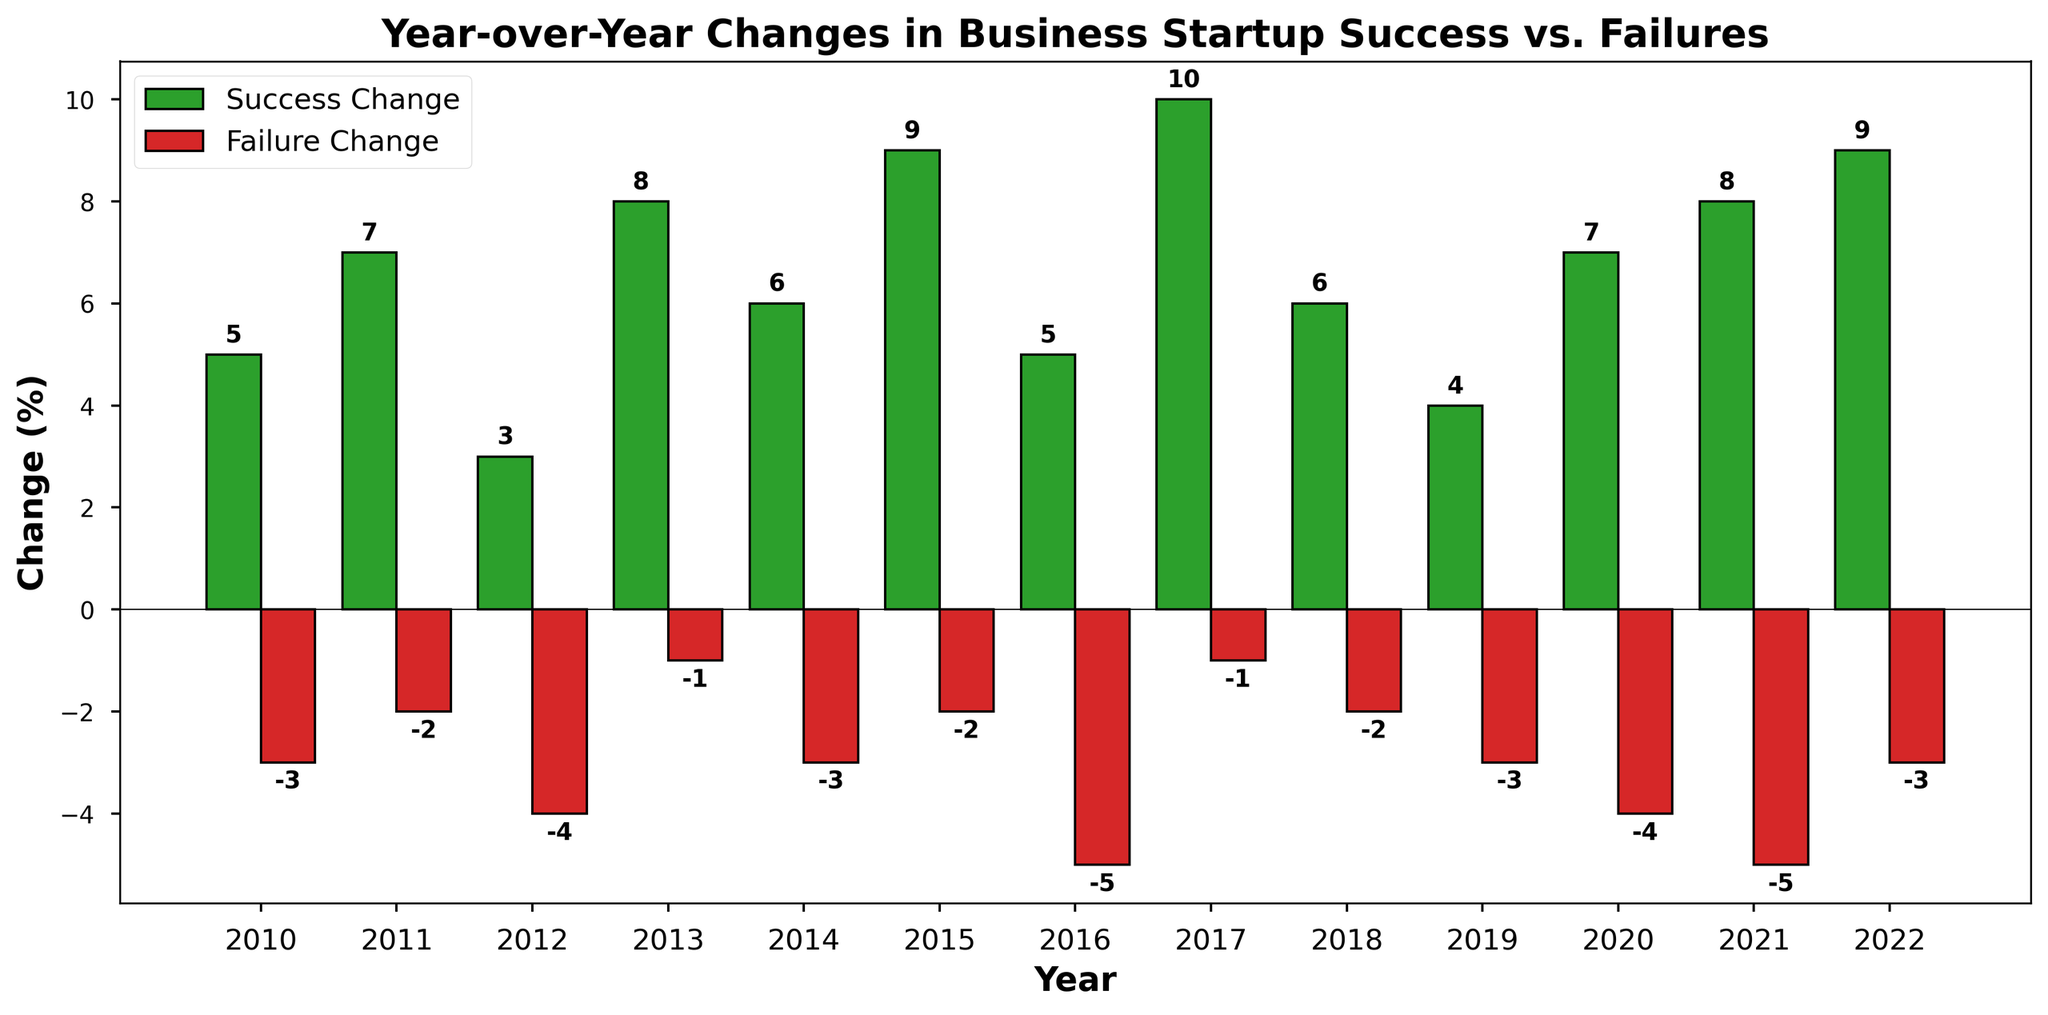In which year did the Startups Success Change have the highest value? The bars representing the Startups Success Change are in green. By visually comparing the heights of these bars, we can see that the highest value is in 2017.
Answer: 2017 What is the total change in Startups Success from 2019 to 2022? Add the values of Startups Success Change for the years 2019, 2020, 2021, and 2022: 4 + 7 + 8 + 9 = 28.
Answer: 28 Comparing 2013 and 2015, which year saw a higher decrease in Startups Failures? The bars representing the Startups Failure Change are in red. Both 2013 and 2015 are shown with red bars, and visually, the height of the red bar in 2013 (-1) is shorter in length compared to 2015 (-2).
Answer: 2015 What is the difference between the Startups Success Change and Startups Failure Change in 2011? The Startups Success Change in 2011 is 7 and the Startups Failure Change is -2. The difference is 7 - (-2) = 7 + 2 = 9.
Answer: 9 Which year had an equal value of Startups Success and Startups Failure Change? Visually, there is no year where the height of the green bar (Success) is equal to the height of the red bar (Failure).
Answer: None How many years had a Startups Success Change greater than 6%? Count the years where the height of the green bars exceeds the 6% mark on the y-axis. The years are 2011, 2013, 2015, 2017, 2020, 2021, and 2022.
Answer: 7 What is the average Startups Failure Change from 2010 to 2022? The values of Startups Failure Change from 2010 to 2022 are: -3, -2, -4, -1, -3, -2, -5, -1, -2, -3, -4, -5, -3. Summing these gives: -3 + -2 + -4 + -1 + -3 + -2 + -5 + -1 + -2 + -3 + -4 + -5 + -3 = -38. Dividing by 13 years, -38 / 13 = -2.92.
Answer: -2.92 What is the cumulative change in Startups Success and Failures in 2016 and 2021 combined? Add the values for Startups Success and Failure Change for the years 2016 and 2021: (5, -5) for 2016 and (8, -5) for 2021. Success Change: 5 + 8 = 13, Failure Change: -5 + -5 = -10.
Answer: 13, -10 